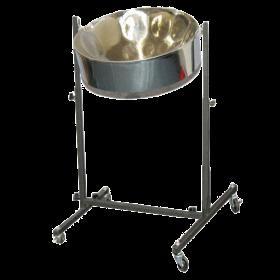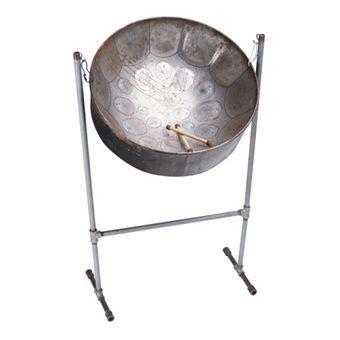The first image is the image on the left, the second image is the image on the right. Evaluate the accuracy of this statement regarding the images: "Each image shows one cylindrical metal drum with a concave top, and the drums on the right and left have similar shaped stands.". Is it true? Answer yes or no. Yes. The first image is the image on the left, the second image is the image on the right. For the images shown, is this caption "Exactly two drums are attached to floor stands, which are different, but with the same style of feet." true? Answer yes or no. Yes. 